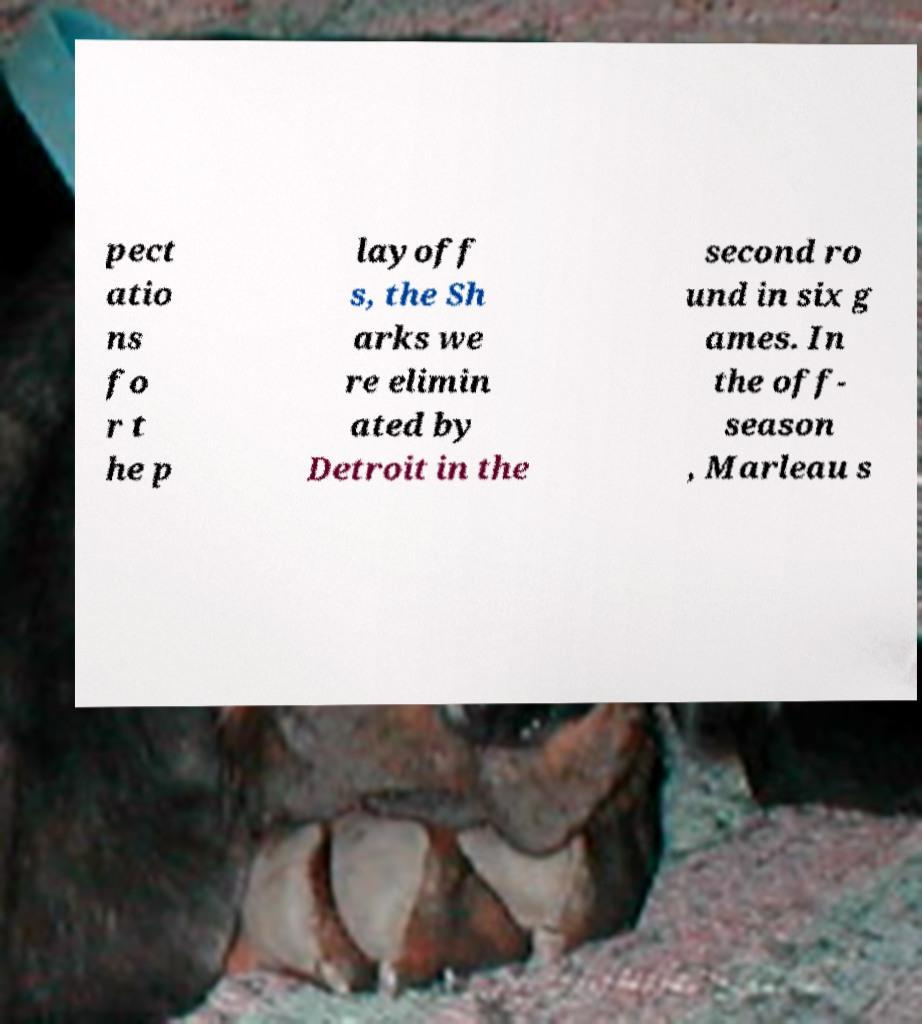Please identify and transcribe the text found in this image. pect atio ns fo r t he p layoff s, the Sh arks we re elimin ated by Detroit in the second ro und in six g ames. In the off- season , Marleau s 